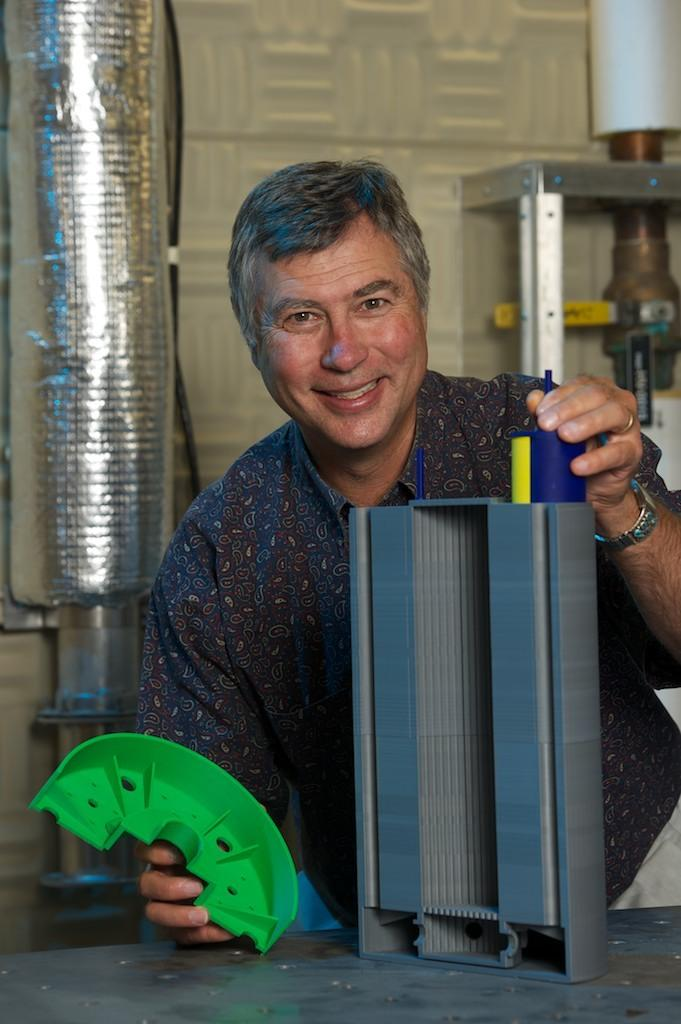What is the main subject of the image? There is a man in the image. What is the man doing in the image? The man is holding objects in his hands. Can you describe the background of the image? There are other items visible in the background of the image. What type of bee can be seen flying around the man in the image? There is no bee present in the image. What is the man eating for lunch in the image? The provided facts do not mention any food or lunch, so it cannot be determined from the image. 